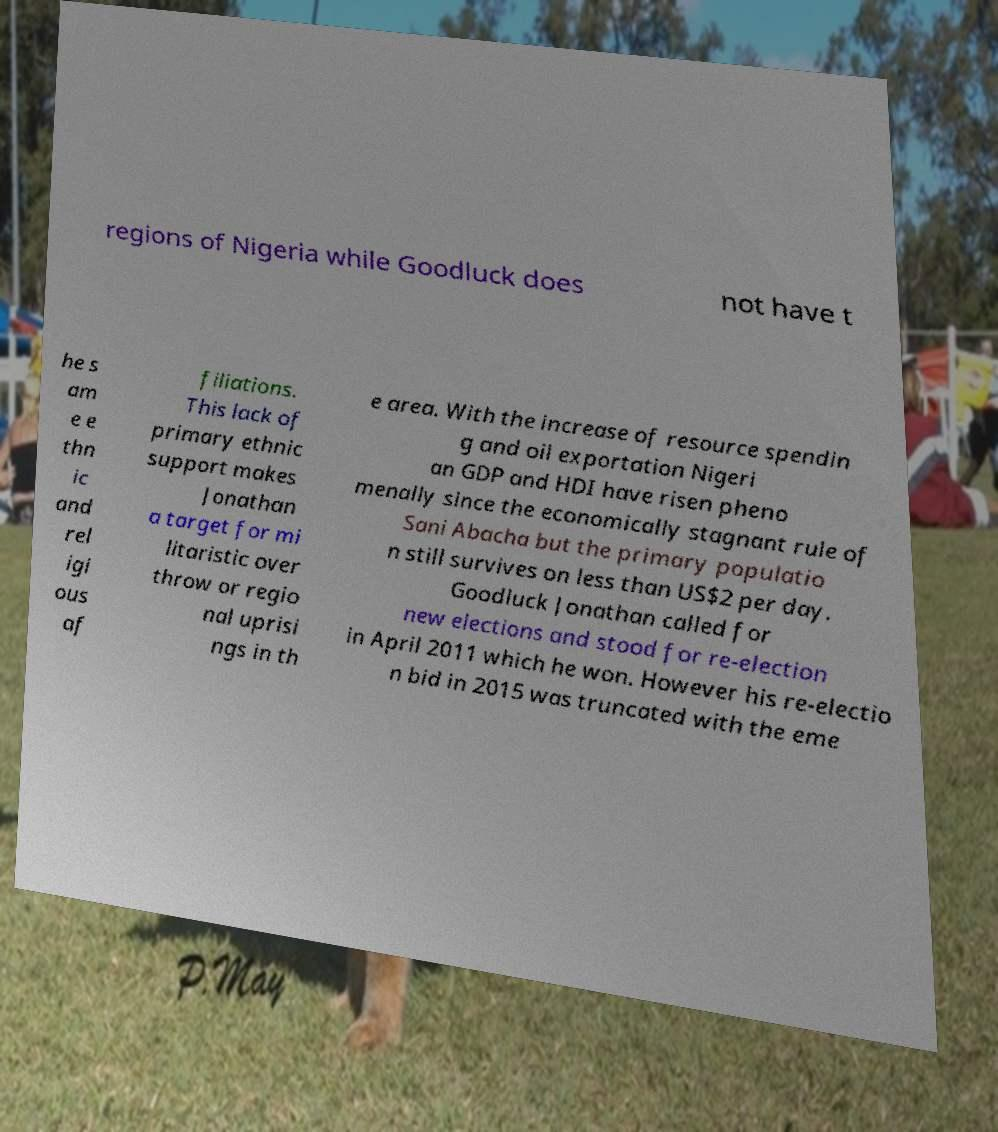I need the written content from this picture converted into text. Can you do that? regions of Nigeria while Goodluck does not have t he s am e e thn ic and rel igi ous af filiations. This lack of primary ethnic support makes Jonathan a target for mi litaristic over throw or regio nal uprisi ngs in th e area. With the increase of resource spendin g and oil exportation Nigeri an GDP and HDI have risen pheno menally since the economically stagnant rule of Sani Abacha but the primary populatio n still survives on less than US$2 per day. Goodluck Jonathan called for new elections and stood for re-election in April 2011 which he won. However his re-electio n bid in 2015 was truncated with the eme 